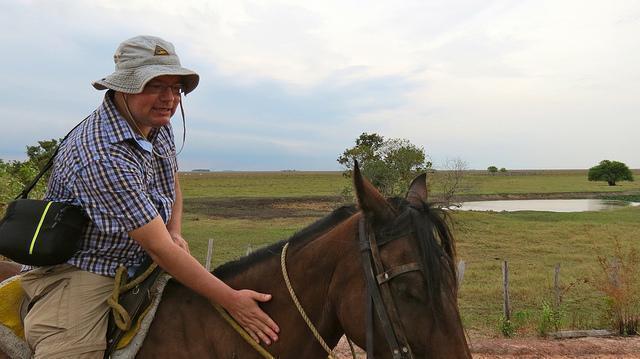What is the man trying to do to the horse?
Answer the question by selecting the correct answer among the 4 following choices.
Options: Punish it, milk it, calm it, feed it. Calm it. 